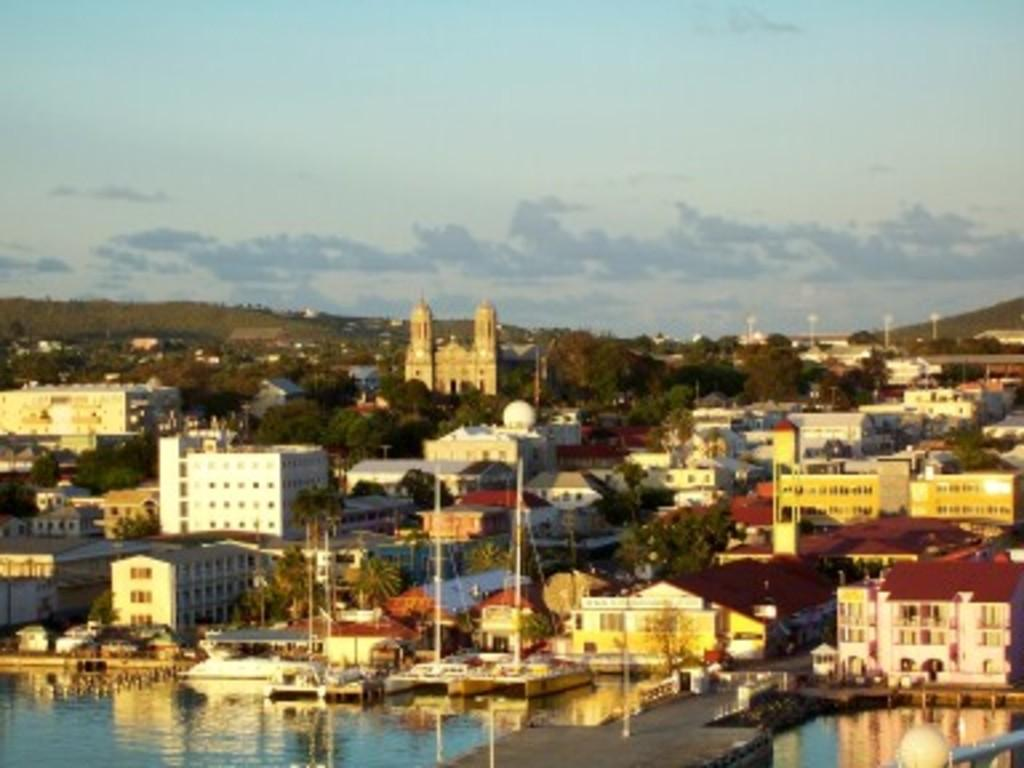What type of structures can be seen in the image? There are buildings in the image. What natural elements are present in the image? There are trees in the image. What is floating on the water in the image? There is a boat in the water in the image. What are the vertical objects in the image? There are poles in the image. How would you describe the sky in the image? The sky is blue and cloudy in the image. What type of veil is draped over the buildings in the image? There is no veil present in the image; the buildings are not covered by any fabric or material. How much zinc is visible in the image? There is no zinc present in the image. 